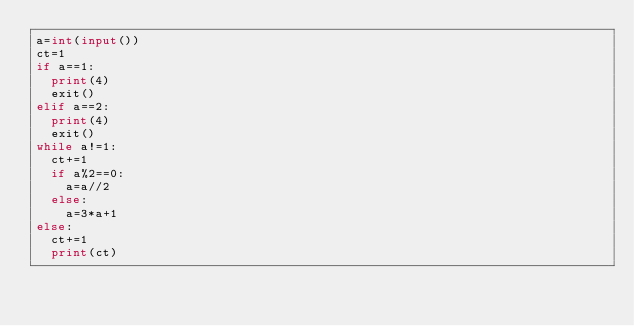Convert code to text. <code><loc_0><loc_0><loc_500><loc_500><_Python_>a=int(input())
ct=1
if a==1:
  print(4)
  exit()
elif a==2:
  print(4)
  exit()
while a!=1:
  ct+=1
  if a%2==0:
    a=a//2
  else:
    a=3*a+1
else:
  ct+=1
  print(ct)
</code> 